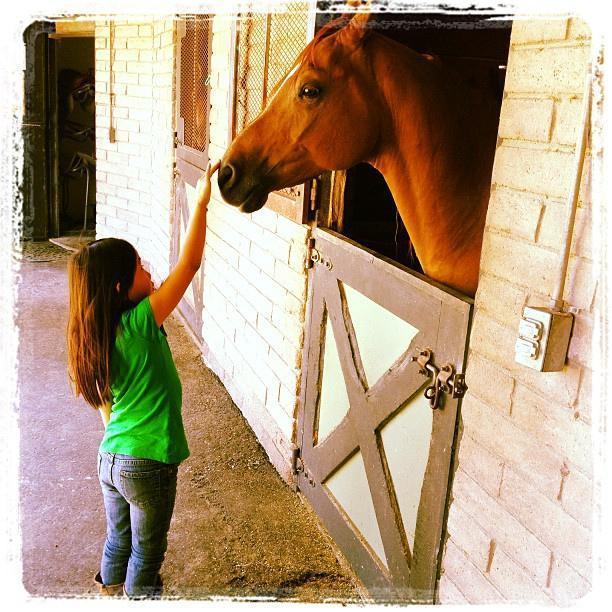How many sinks are there?
Give a very brief answer. 0. 